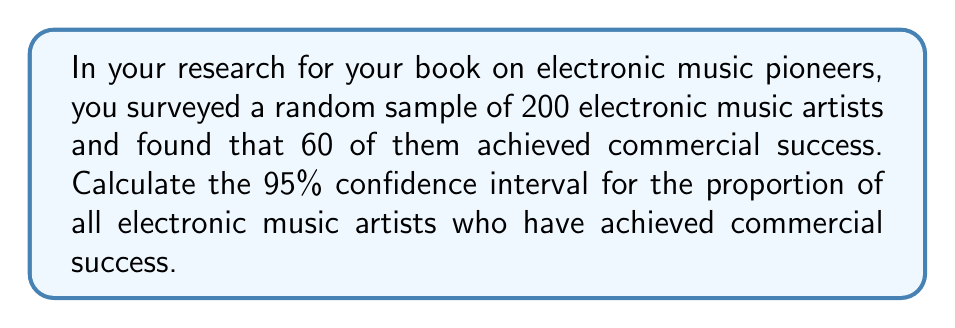What is the answer to this math problem? Let's approach this step-by-step:

1) First, we need to calculate the sample proportion $\hat{p}$:
   $\hat{p} = \frac{\text{number of successes}}{\text{sample size}} = \frac{60}{200} = 0.3$

2) The formula for the confidence interval is:
   $$\hat{p} \pm z_{\alpha/2} \sqrt{\frac{\hat{p}(1-\hat{p})}{n}}$$
   
   Where:
   - $\hat{p}$ is the sample proportion
   - $z_{\alpha/2}$ is the critical value (for 95% confidence, this is 1.96)
   - $n$ is the sample size

3) Let's substitute our values:
   $$0.3 \pm 1.96 \sqrt{\frac{0.3(1-0.3)}{200}}$$

4) Simplify inside the square root:
   $$0.3 \pm 1.96 \sqrt{\frac{0.3(0.7)}{200}}$$

5) Calculate:
   $$0.3 \pm 1.96 \sqrt{0.00105} = 0.3 \pm 1.96(0.0324)$$

6) Multiply:
   $$0.3 \pm 0.0635$$

7) Therefore, the confidence interval is:
   $$(0.3 - 0.0635, 0.3 + 0.0635) = (0.2365, 0.3635)$$

We can say with 95% confidence that the true proportion of electronic music artists who have achieved commercial success is between 23.65% and 36.35%.
Answer: (0.2365, 0.3635) 